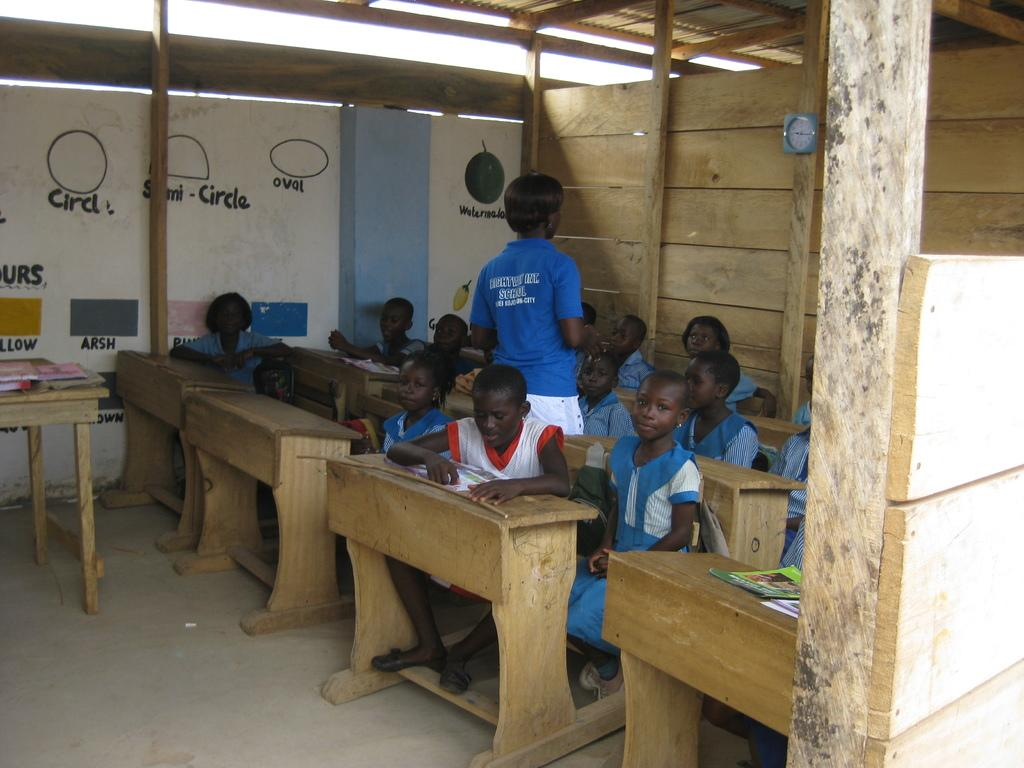What are the people sitting on in the image? The people are sitting on wooden chairs. Can you describe the woman's position in the image? A woman is standing on the right side. What type of furniture is in the image besides the chairs? There is a wooden table in the image. What items can be seen on the wooden table? Books are present on the wooden table. What type of coach is the woman driving in the image? There is no coach present in the image; it features people sitting on wooden chairs and a woman standing on the right side. What design elements can be seen on the books on the wooden table? The provided facts do not mention any design elements on the books; they only mention the presence of books on the wooden table. 